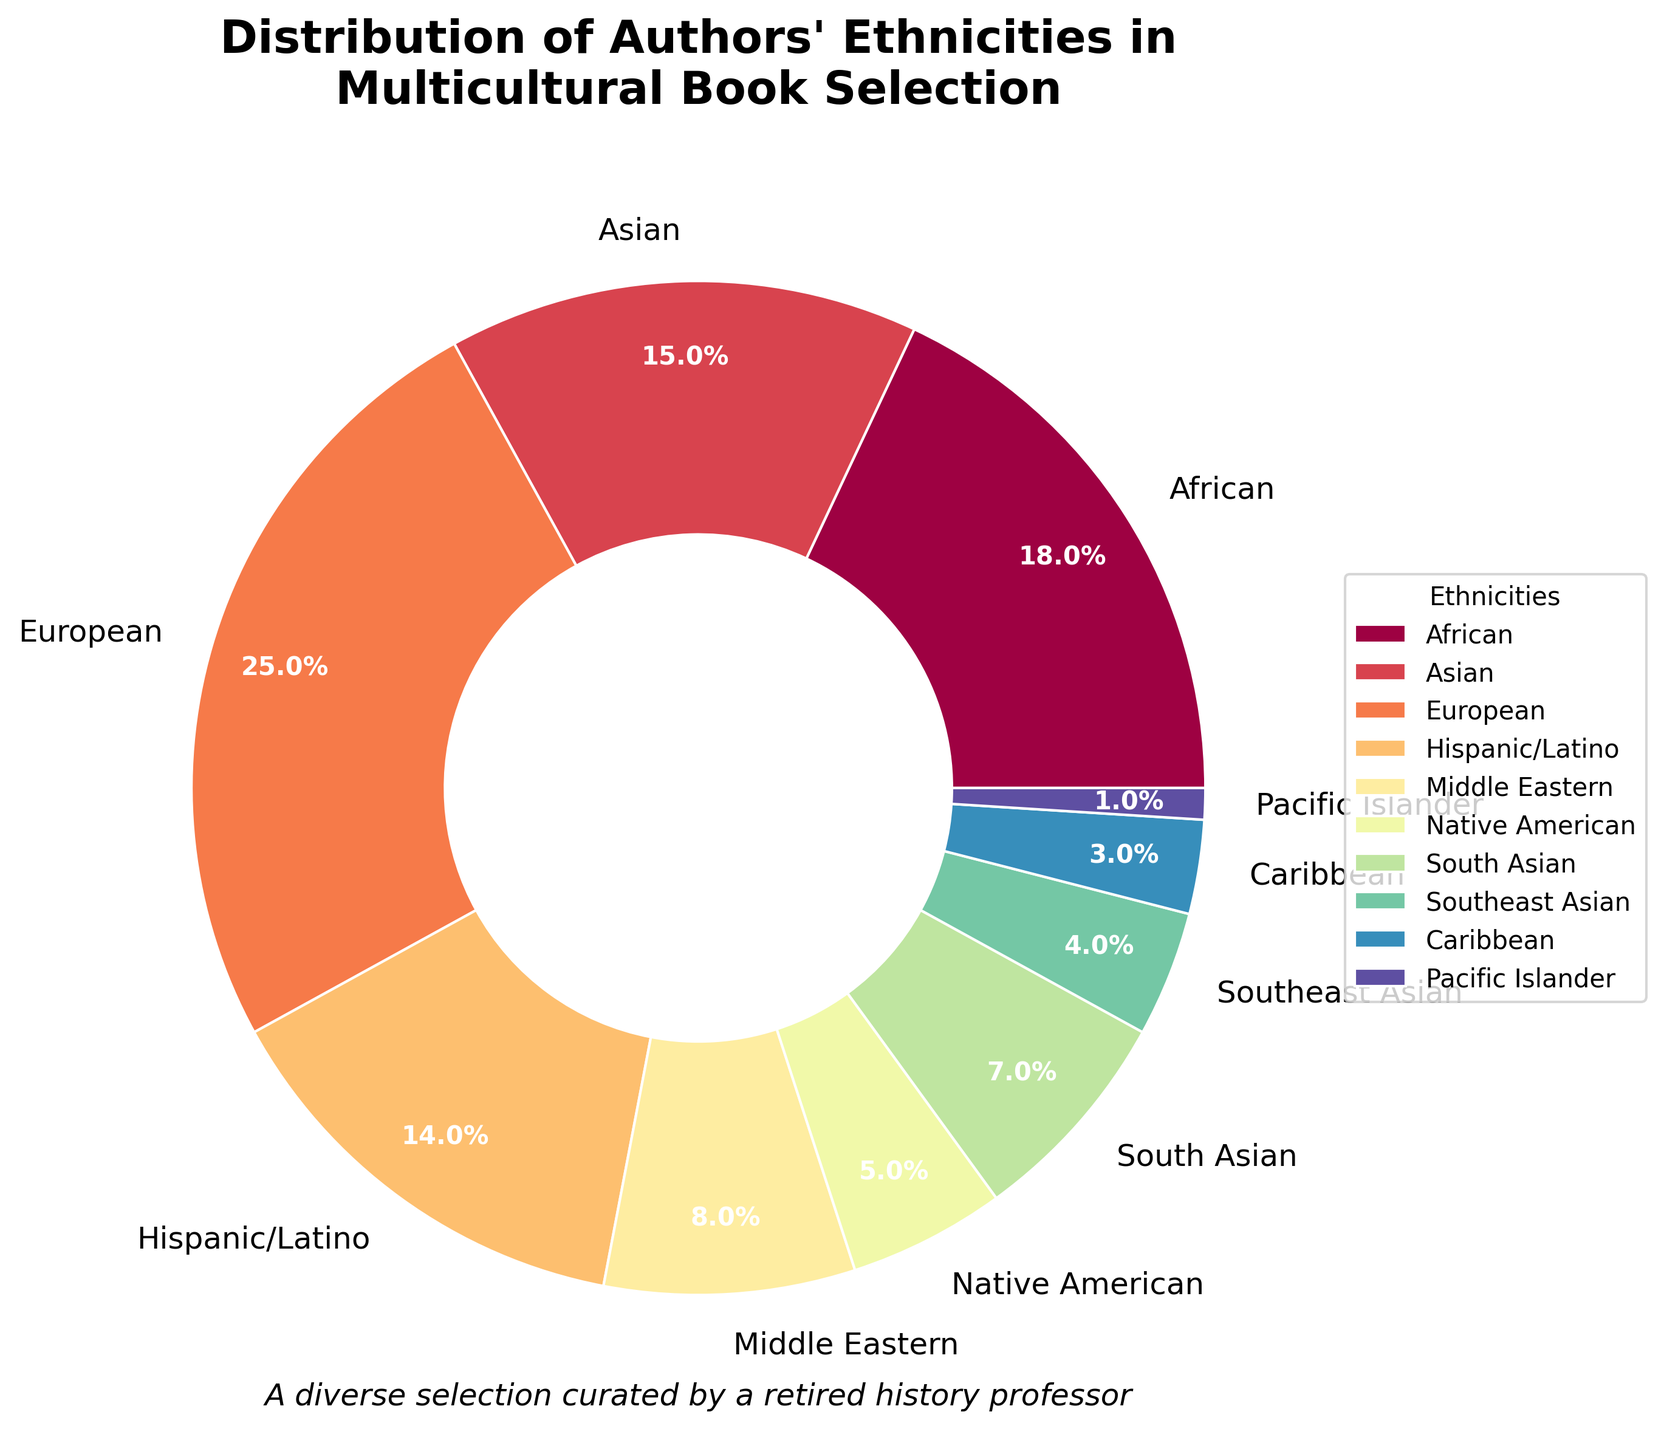What ethnicity has the largest representation in the book selection? The pie chart shows that the European ethnicity has the largest percentage with 25%.
Answer: European Which ethnic group has a higher percentage: African or Asian? The pie chart shows that the African ethnicity is 18% and the Asian ethnicity is 15%. 18% is greater than 15%.
Answer: African What is the combined percentage of Native American and Pacific Islander authors? According to the pie chart, Native American is represented by 5% and Pacific Islander by 1%. Adding these together: 5% + 1% = 6%.
Answer: 6% How many ethnicities have a representation of 10% or greater? From inspecting the pie chart's percentages, African (18%), Asian (15%), European (25%), and Hispanic/Latino (14%) are the ethnicities with 10% or greater, totaling 4 groups.
Answer: 4 What is the difference in percentage between the most and least represented ethnicities? The most represented ethnicity is European with 25% and the least represented is Pacific Islander with 1%. The difference is 25% - 1% = 24%.
Answer: 24% Are there more South Asian authors or Native American authors in the selection? The chart shows that South Asian authors make up 7% while Native American authors make up 5%. Since 7% is greater than 5%, there are more South Asian authors.
Answer: South Asian Which groups combined make up the smallest segment of the pie chart? The smallest segments are Caribbean (3%) and Pacific Islander (1%), whose combined percentage is 3% + 1% = 4%.
Answer: Caribbean and Pacific Islander How does the percentage of Southeast Asian authors compare to Middle Eastern authors? The pie chart shows Southeast Asian authors are 4% and Middle Eastern authors are 8%. Since 4% is less than 8%, Southeast Asian authors are less represented.
Answer: Southeast Asian authors are less represented What's the average percentage representation of Hispanic/Latino and Middle Eastern authors? Hispanic/Latino represents 14% and Middle Eastern represents 8%. Calculating the average: (14% + 8%) / 2 = 11%.
Answer: 11% What combined percentage of the book selection is represented by African, Asian, and Middle Eastern authors? According to the pie chart, African authors are 18%, Asian authors are 15%, and Middle Eastern authors are 8%. Adding them together: 18% + 15% + 8% = 41%.
Answer: 41% 